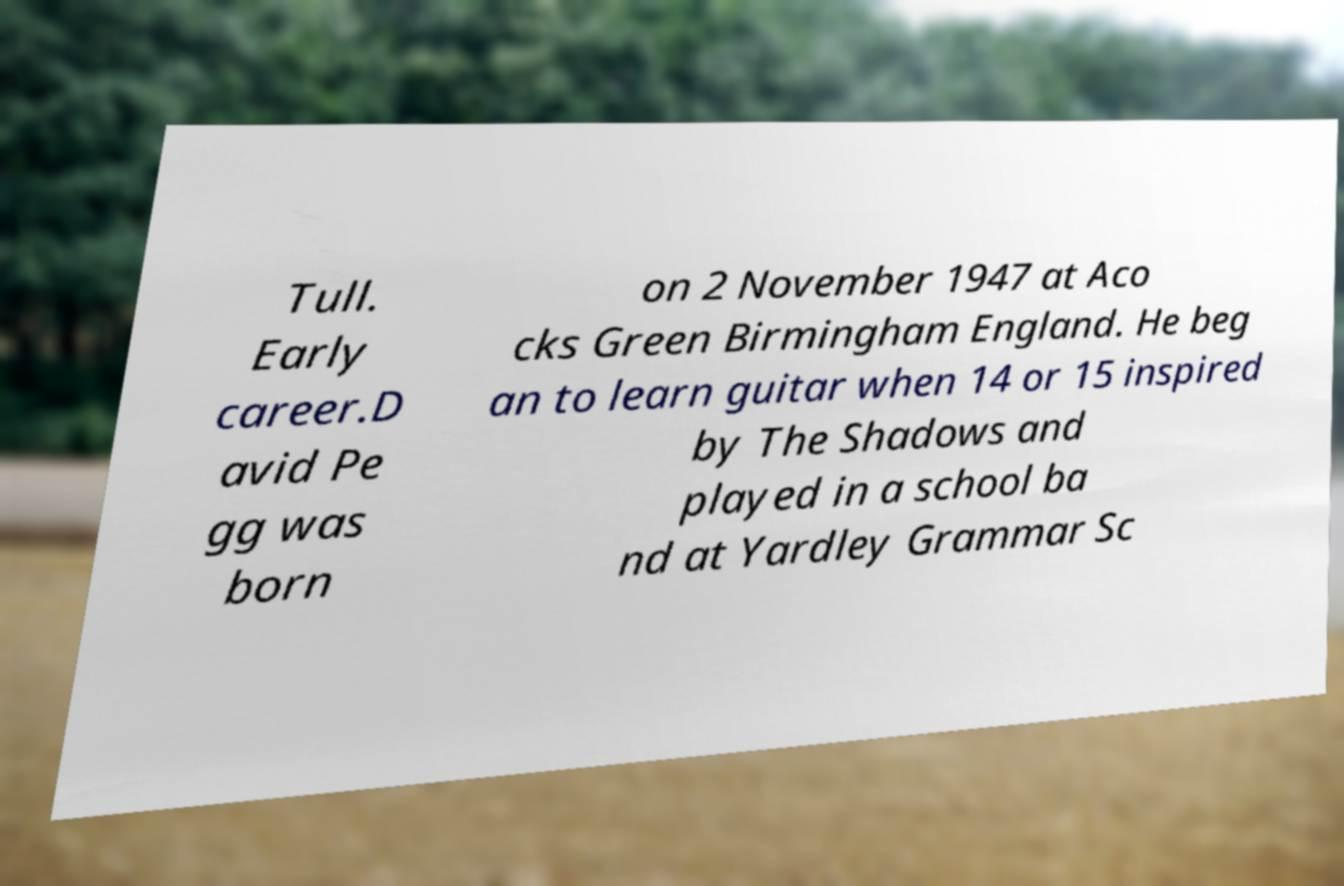Please read and relay the text visible in this image. What does it say? Tull. Early career.D avid Pe gg was born on 2 November 1947 at Aco cks Green Birmingham England. He beg an to learn guitar when 14 or 15 inspired by The Shadows and played in a school ba nd at Yardley Grammar Sc 